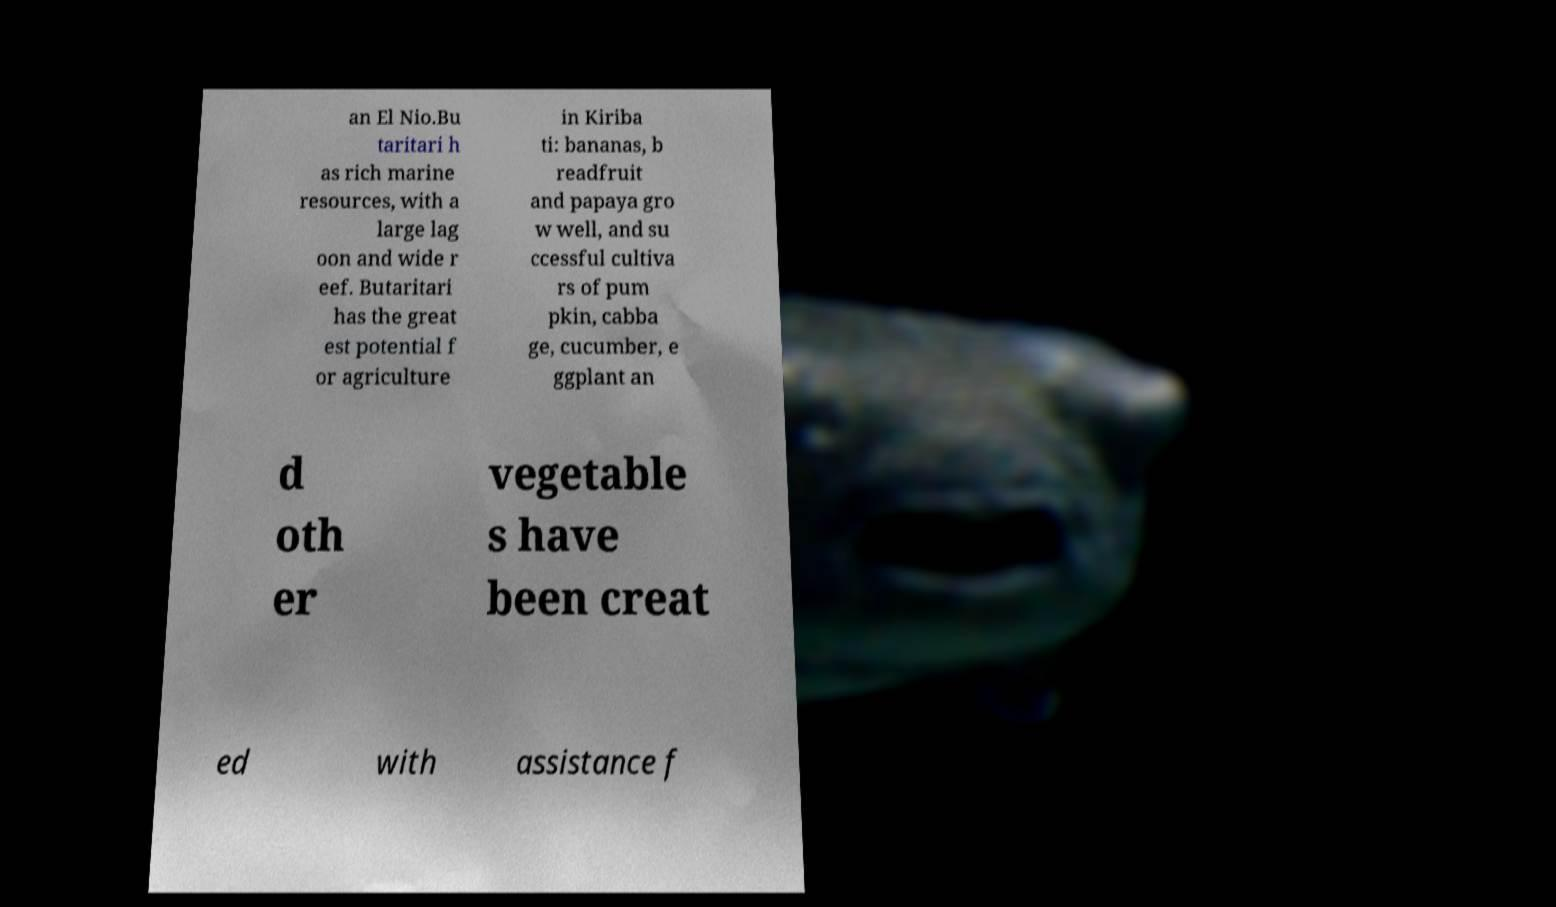Can you accurately transcribe the text from the provided image for me? an El Nio.Bu taritari h as rich marine resources, with a large lag oon and wide r eef. Butaritari has the great est potential f or agriculture in Kiriba ti: bananas, b readfruit and papaya gro w well, and su ccessful cultiva rs of pum pkin, cabba ge, cucumber, e ggplant an d oth er vegetable s have been creat ed with assistance f 